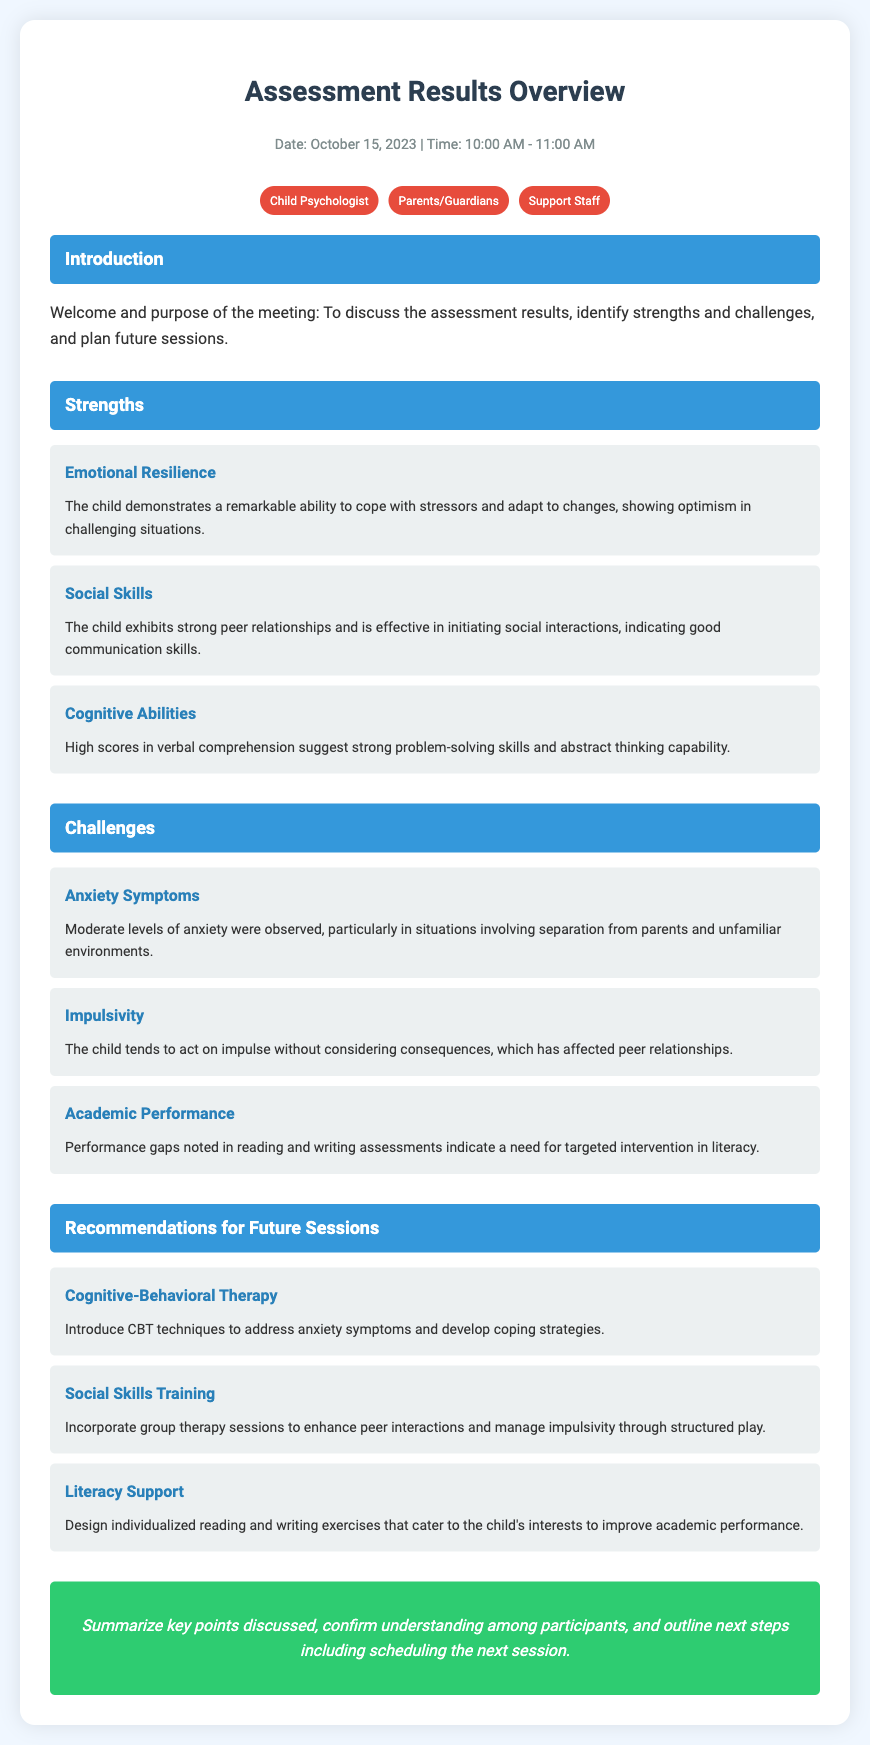What is the date of the assessment? The date of the assessment is explicitly stated at the beginning of the document.
Answer: October 15, 2023 What was one observed strength in social skills? The document lists specific strengths in a section. One strength includes the child's ability to initiate social interactions.
Answer: Strong peer relationships What level of anxiety was observed? The document mentions the level of anxiety noted during the assessment.
Answer: Moderate What therapy is recommended to address anxiety symptoms? A specific therapy option is mentioned as a recommendation for addressing anxiety in the document.
Answer: Cognitive-Behavioral Therapy What is one academic challenge identified for the child? The document highlights specific challenges, including issues with academic performance in assessments.
Answer: Performance gaps in reading What type of training is recommended to manage impulsivity? The recommendations section includes various types of interventions, including training aimed at improving impulse control.
Answer: Social Skills Training How long did the assessment meeting last? The document specifies the duration of the meeting in the header information.
Answer: 1 hour What emotional strength does the child demonstrate? The strengths section describes the child's ability to handle stress and adapt well.
Answer: Emotional Resilience What is one suggested method to enhance academic performance? The document contains recommendations for specific methods aimed at improving the child's academic skills.
Answer: Individualized reading exercises 